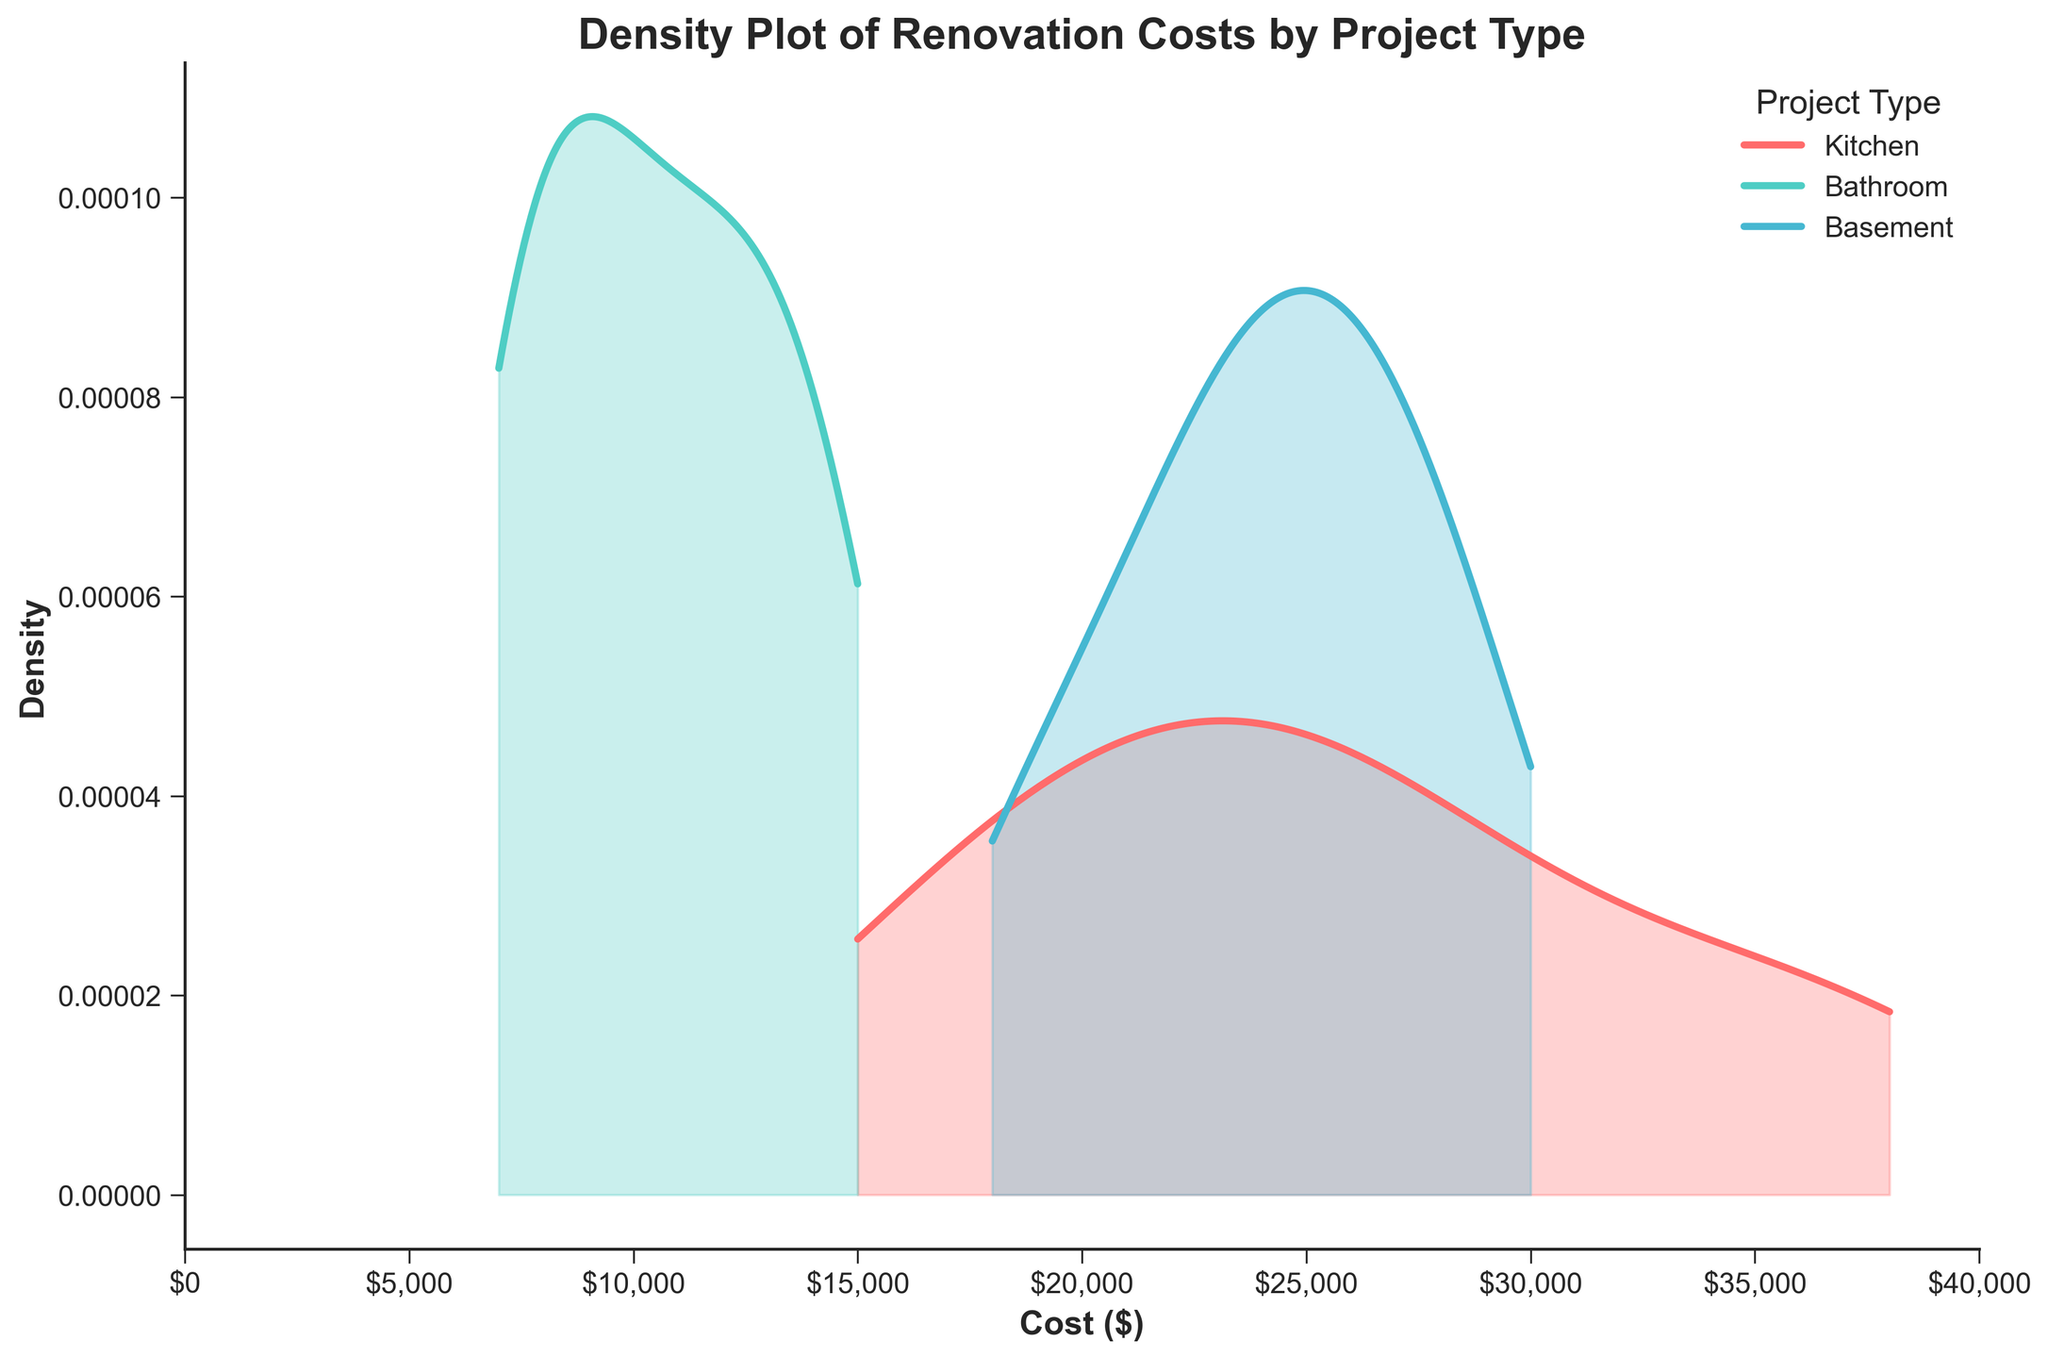What is the title of the figure? The title of a plot is usually found at the top center. By looking at the top center of the figure, we see the title text.
Answer: Density Plot of Renovation Costs by Project Type What are the units on the x-axis? The x-axis units are typically labeled directly beneath the axis. By looking at the bottom of the figure, we see that the x-axis label is "Cost ($)", indicating the units are in dollars.
Answer: Dollars Which project type appears to have the highest peak density? Identify the highest peak for each line in the plot. The project type with the highest peak is the one that reaches the highest density. The plot shows that the Kitchen's curve has the highest peak.
Answer: Kitchen Is the density distribution for Bathroom renovations wider or narrower compared to Kitchen renovations? Observe the spread of the density curves. A wider distribution will have a longer spread on the x-axis, while a narrower distribution will be more concentrated. The Bathroom curve is narrower compared to the Kitchen curve, meaning Bathroom renovations are more concentrated around certain costs.
Answer: Narrower What can you infer about the cost range for Basement renovations compared to Bathroom renovations? Look at the x-axis range where each project's density curve lies. The Basement renovations curve is spread across a wider cost range (from around 18,000 to 30,000 dollars), while the Bathroom renovations curve is more concentrated between 7,000 and 15,000 dollars.
Answer: Basement renovations have a wider cost range Which project type has the lowest starting cost? Determine the starting point of each density curve on the x-axis. The Bathroom renovation density curve starts at about 7,000 dollars, which is lower than the starting costs for Kitchen and Basement projects.
Answer: Bathroom Between the Kitchen and Basement projects, which has a higher maximum renovation cost density? Observe the heights of the peaks for Kitchen and Basement density curves. The Kitchen project type has a maximum peak that is higher than the peak for Basement renovations.
Answer: Kitchen How does the spread of costs for Kitchen renovations compare to Basement renovations? Examine how stretched each density curve is along the x-axis. The Kitchen renovation costs are more spread out (from about 15,000 to 38,000 dollars) compared to Basement renovations, which are spread from about 18,000 to 30,000 dollars.
Answer: Kitchen renovations are more spread out 